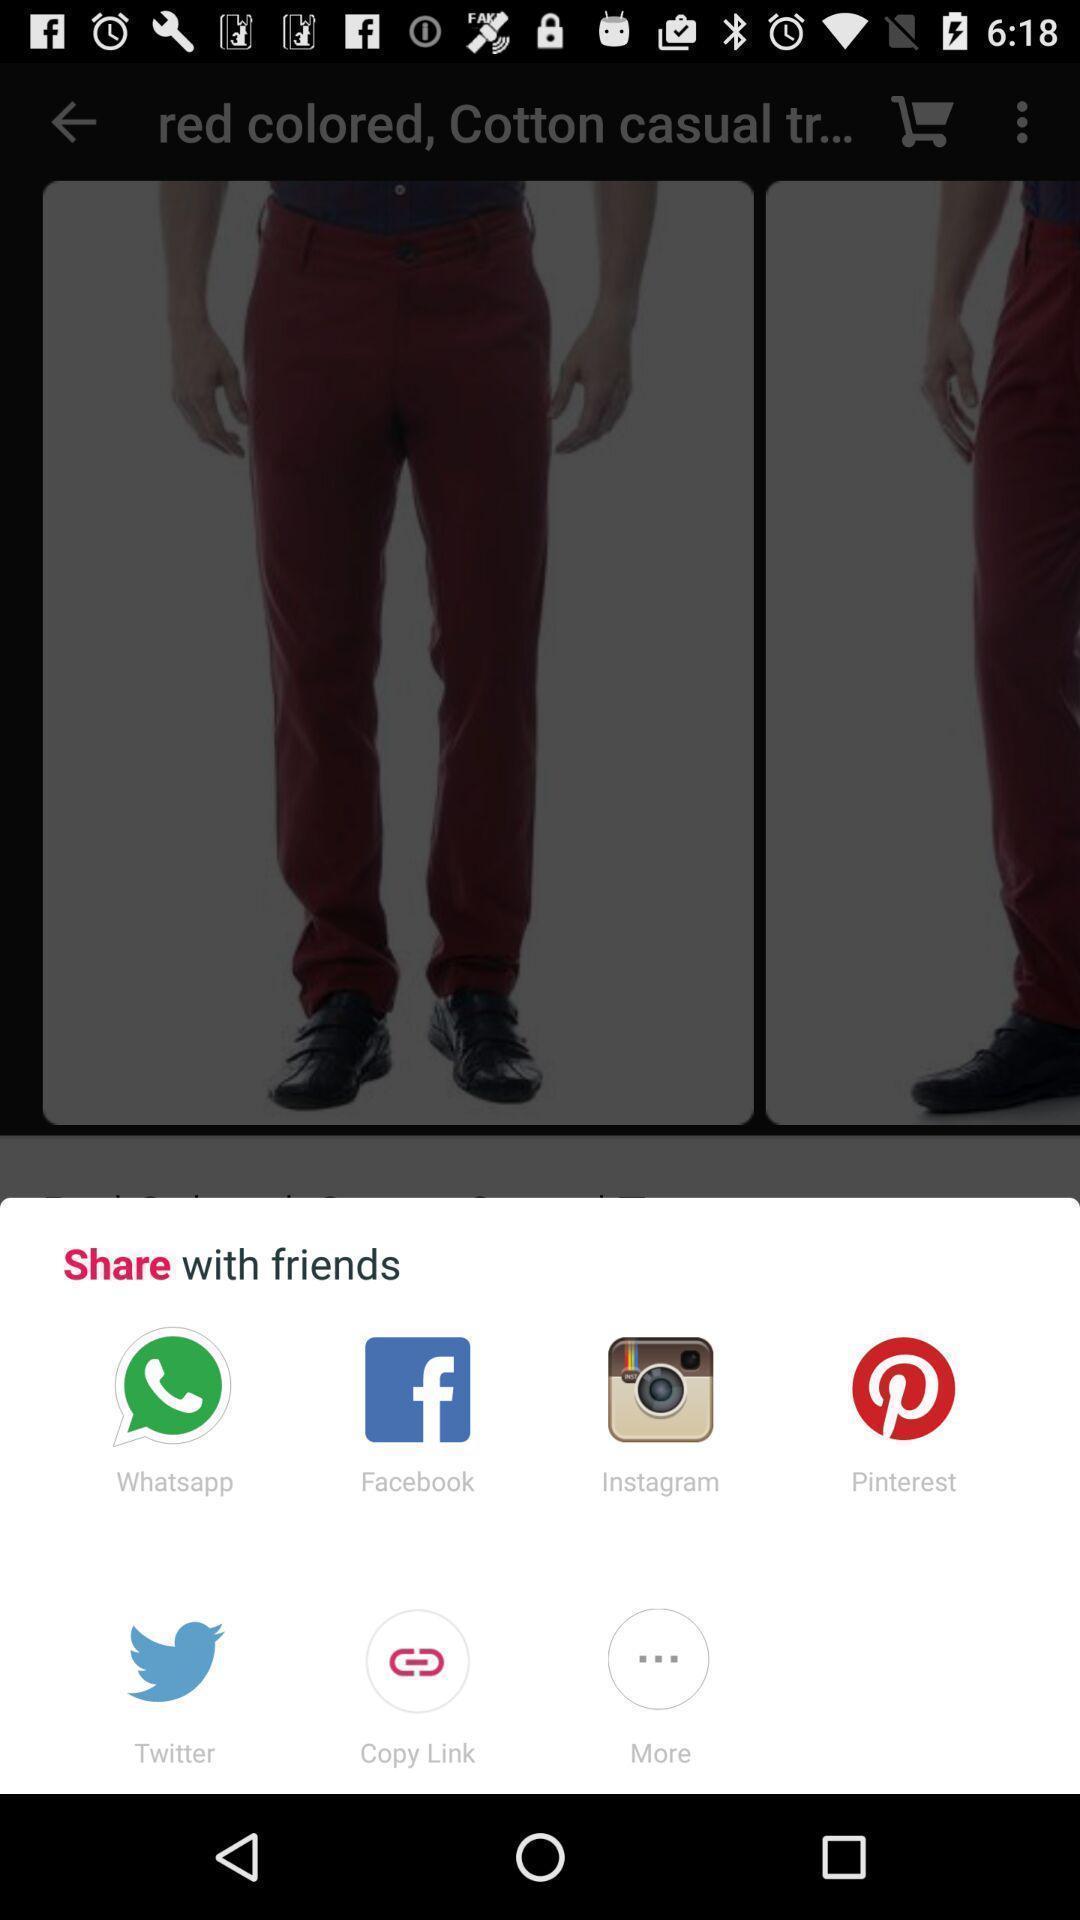Describe this image in words. Push up message for sharing data via social network. 